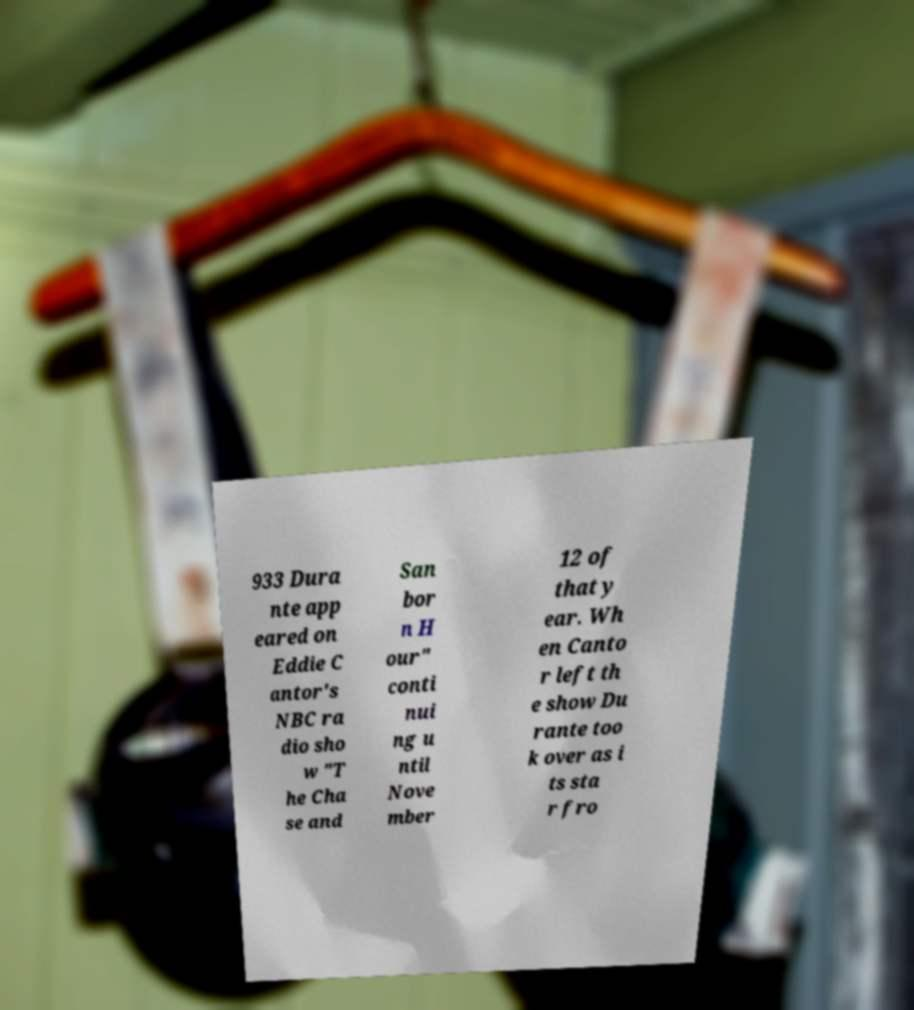For documentation purposes, I need the text within this image transcribed. Could you provide that? 933 Dura nte app eared on Eddie C antor's NBC ra dio sho w "T he Cha se and San bor n H our" conti nui ng u ntil Nove mber 12 of that y ear. Wh en Canto r left th e show Du rante too k over as i ts sta r fro 